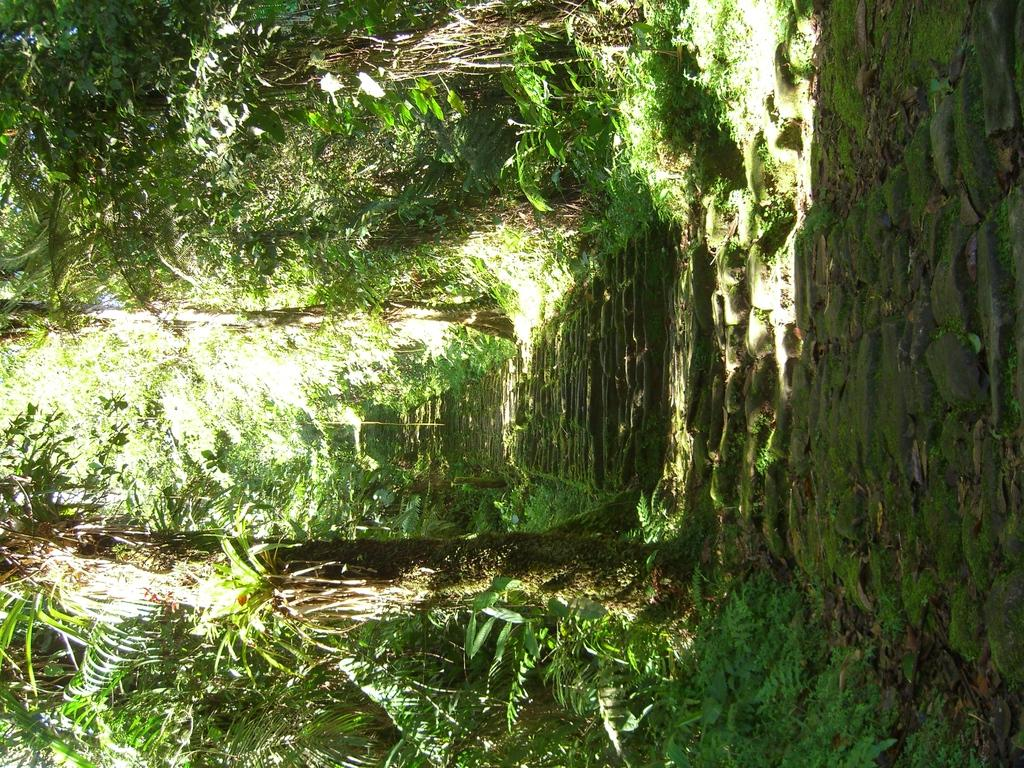What is the main subject of the image? The main subject of the image is a group of trees. Can you describe the location of the trees in the image? The trees are located in the center of the image. What type of vegetation is depicted in the image? The image features trees. What type of person can be seen interacting with the trees in the image? There are no people present in the image; it only features trees. What substance is being used to fertilize the trees in the image? There is no substance visible in the image, as it only features trees. What type of bear can be seen climbing one of the trees in the image? There are no bears present in the image; it only features trees. 